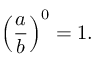<formula> <loc_0><loc_0><loc_500><loc_500>\left ( { \frac { a } { b } } \right ) ^ { 0 } = 1 .</formula> 